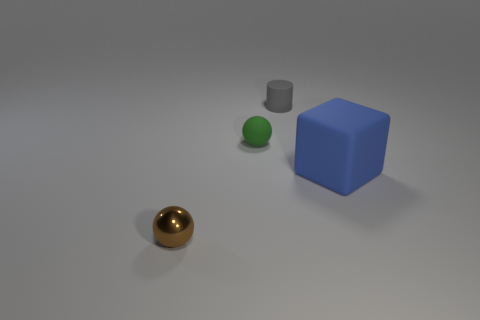Are there any other things that have the same size as the rubber cube?
Make the answer very short. No. How many green matte cylinders are there?
Provide a short and direct response. 0. There is a matte thing behind the tiny rubber object to the left of the rubber object that is behind the green rubber ball; what is its color?
Provide a short and direct response. Gray. Is the material of the tiny green object the same as the tiny sphere that is in front of the rubber block?
Your answer should be very brief. No. What material is the tiny brown thing?
Ensure brevity in your answer.  Metal. How many other objects are the same material as the small gray cylinder?
Provide a succinct answer. 2. What shape is the rubber object that is both to the left of the large rubber cube and in front of the tiny gray matte cylinder?
Keep it short and to the point. Sphere. What color is the block that is made of the same material as the small gray cylinder?
Provide a succinct answer. Blue. Are there an equal number of small brown balls behind the matte sphere and big red cubes?
Your answer should be compact. Yes. There is a gray thing that is the same size as the green thing; what shape is it?
Your response must be concise. Cylinder. 